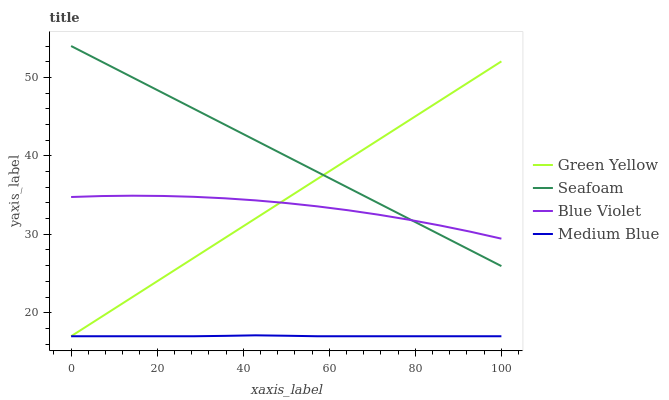Does Medium Blue have the minimum area under the curve?
Answer yes or no. Yes. Does Seafoam have the maximum area under the curve?
Answer yes or no. Yes. Does Seafoam have the minimum area under the curve?
Answer yes or no. No. Does Medium Blue have the maximum area under the curve?
Answer yes or no. No. Is Green Yellow the smoothest?
Answer yes or no. Yes. Is Blue Violet the roughest?
Answer yes or no. Yes. Is Medium Blue the smoothest?
Answer yes or no. No. Is Medium Blue the roughest?
Answer yes or no. No. Does Green Yellow have the lowest value?
Answer yes or no. Yes. Does Seafoam have the lowest value?
Answer yes or no. No. Does Seafoam have the highest value?
Answer yes or no. Yes. Does Medium Blue have the highest value?
Answer yes or no. No. Is Medium Blue less than Blue Violet?
Answer yes or no. Yes. Is Blue Violet greater than Medium Blue?
Answer yes or no. Yes. Does Blue Violet intersect Green Yellow?
Answer yes or no. Yes. Is Blue Violet less than Green Yellow?
Answer yes or no. No. Is Blue Violet greater than Green Yellow?
Answer yes or no. No. Does Medium Blue intersect Blue Violet?
Answer yes or no. No. 